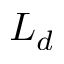Convert formula to latex. <formula><loc_0><loc_0><loc_500><loc_500>L _ { d }</formula> 